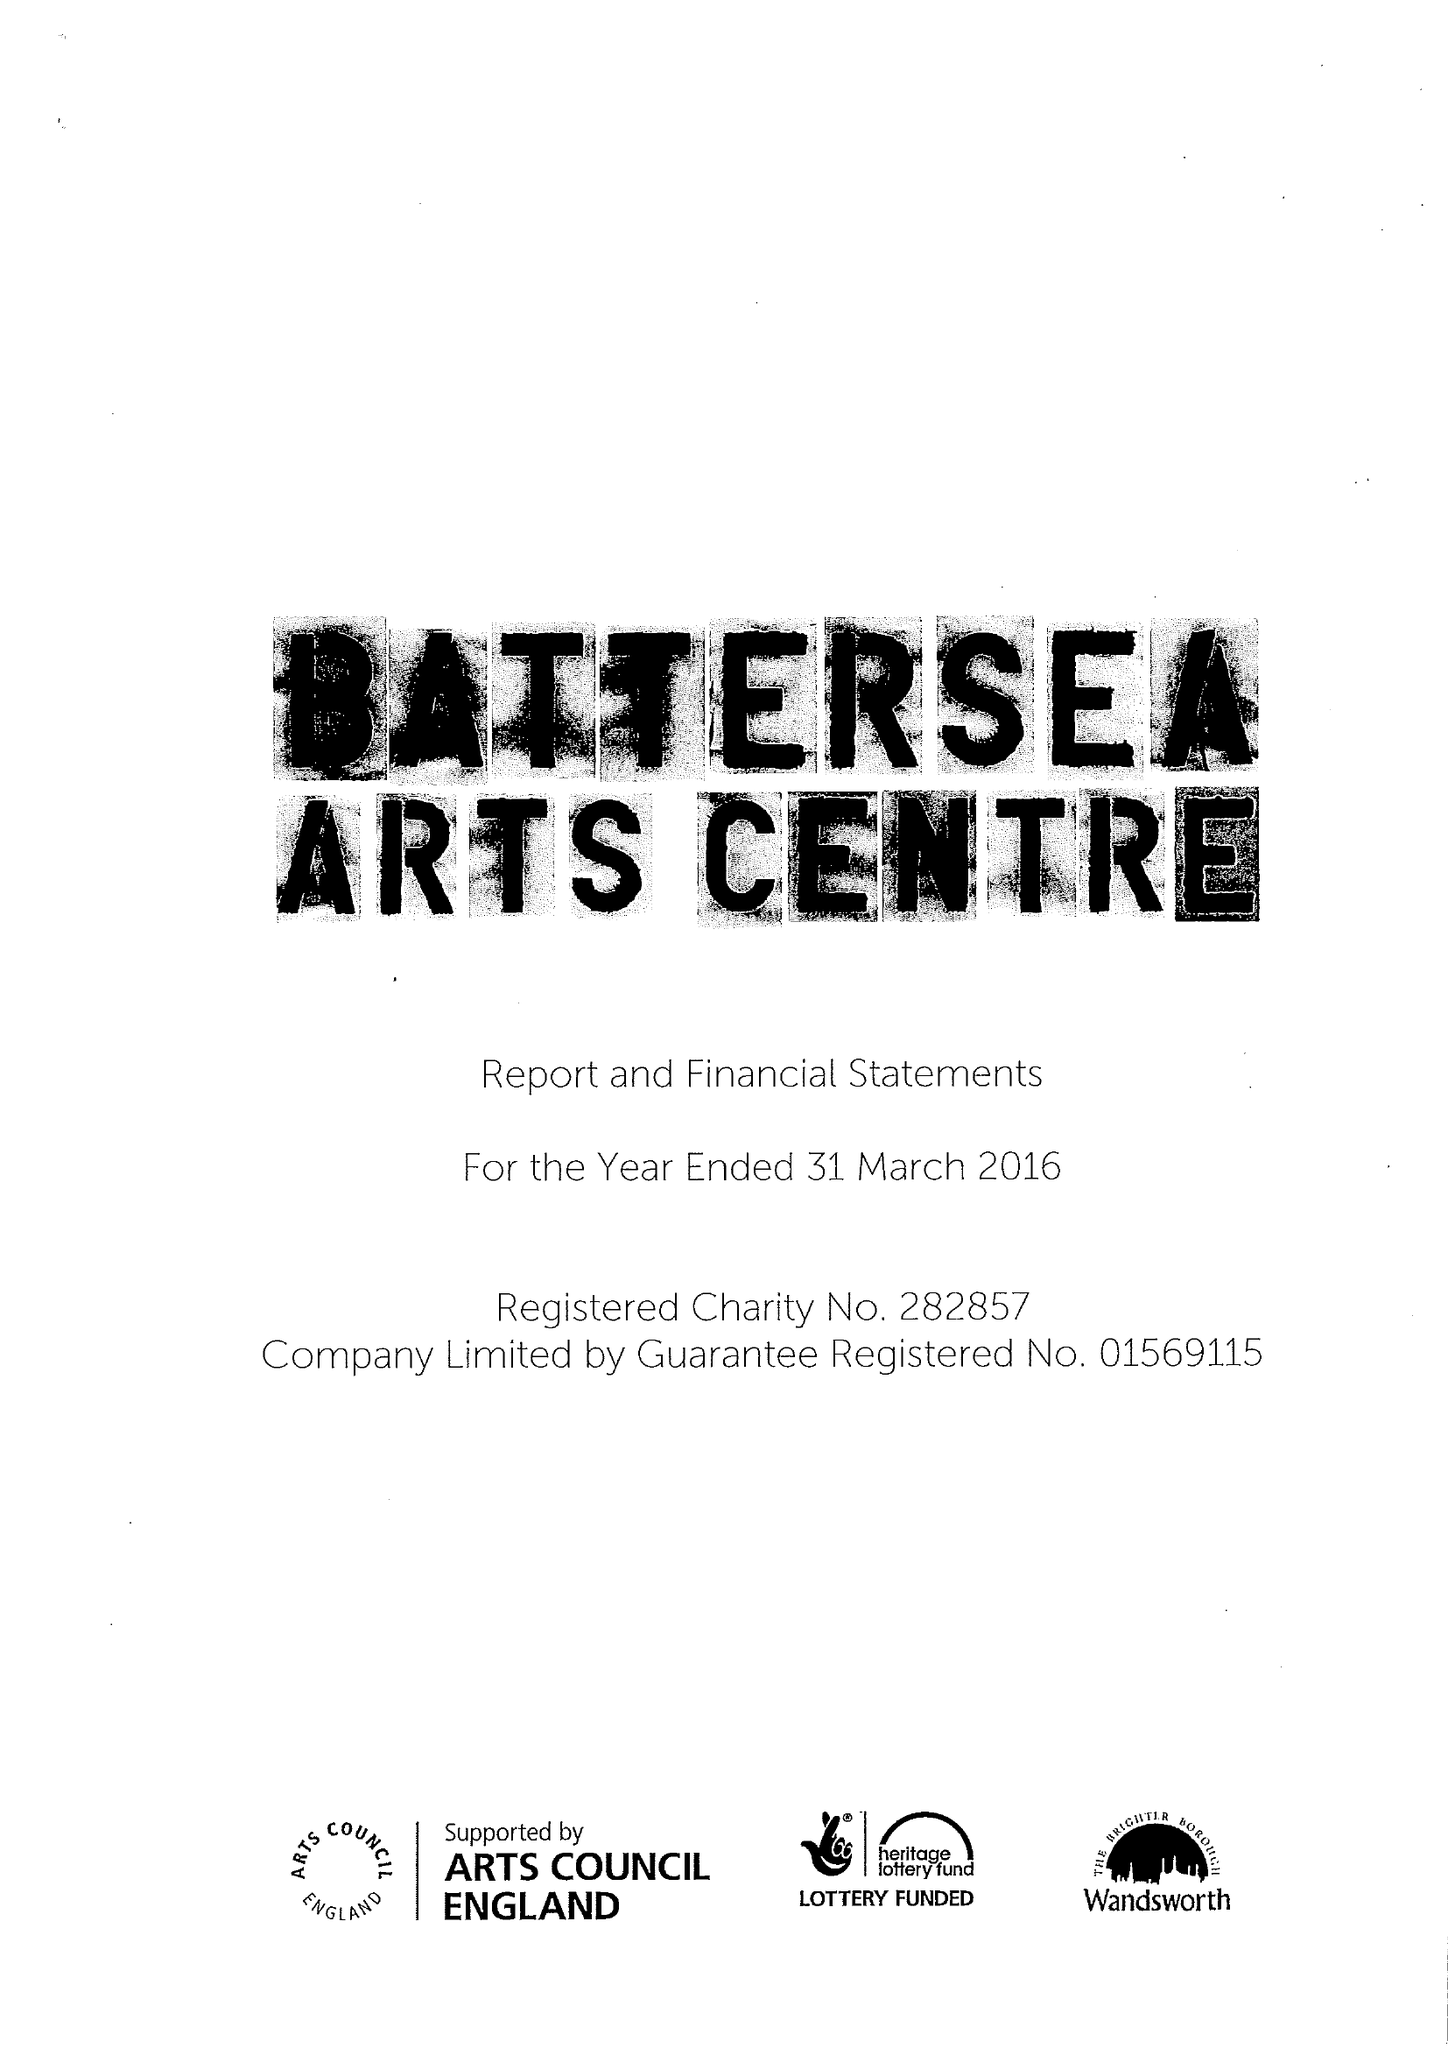What is the value for the address__postcode?
Answer the question using a single word or phrase. SW11 5TN 